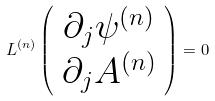Convert formula to latex. <formula><loc_0><loc_0><loc_500><loc_500>L ^ { ( n ) } \left ( \begin{array} { c } \partial _ { j } \psi ^ { ( n ) } \\ \partial _ { j } A ^ { ( n ) } \end{array} \right ) = 0</formula> 